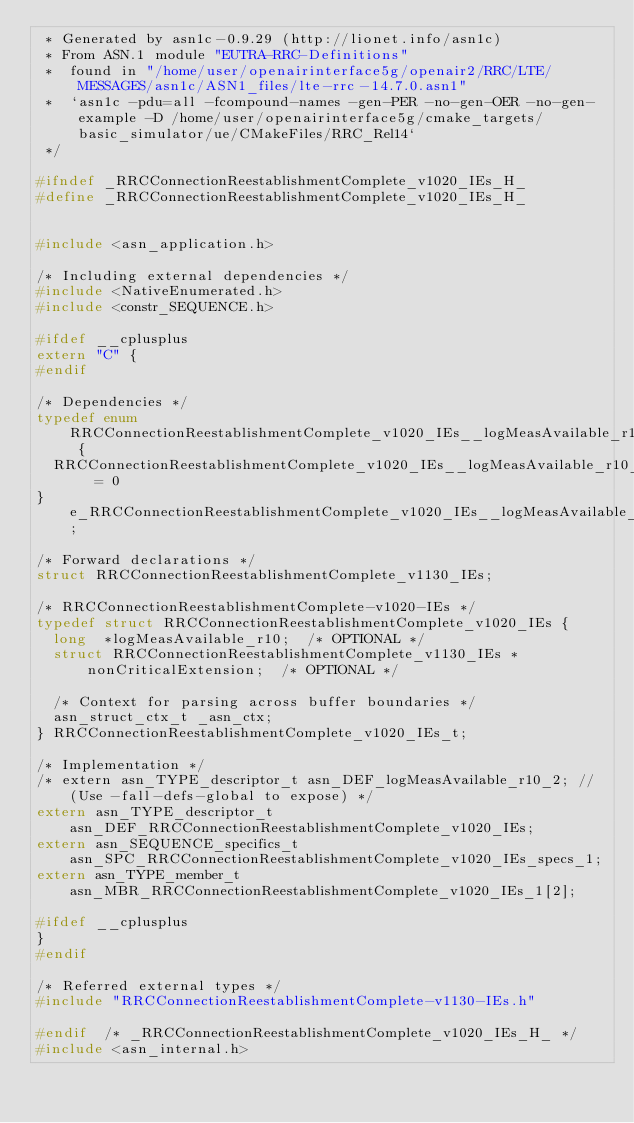Convert code to text. <code><loc_0><loc_0><loc_500><loc_500><_C_> * Generated by asn1c-0.9.29 (http://lionet.info/asn1c)
 * From ASN.1 module "EUTRA-RRC-Definitions"
 * 	found in "/home/user/openairinterface5g/openair2/RRC/LTE/MESSAGES/asn1c/ASN1_files/lte-rrc-14.7.0.asn1"
 * 	`asn1c -pdu=all -fcompound-names -gen-PER -no-gen-OER -no-gen-example -D /home/user/openairinterface5g/cmake_targets/basic_simulator/ue/CMakeFiles/RRC_Rel14`
 */

#ifndef	_RRCConnectionReestablishmentComplete_v1020_IEs_H_
#define	_RRCConnectionReestablishmentComplete_v1020_IEs_H_


#include <asn_application.h>

/* Including external dependencies */
#include <NativeEnumerated.h>
#include <constr_SEQUENCE.h>

#ifdef __cplusplus
extern "C" {
#endif

/* Dependencies */
typedef enum RRCConnectionReestablishmentComplete_v1020_IEs__logMeasAvailable_r10 {
	RRCConnectionReestablishmentComplete_v1020_IEs__logMeasAvailable_r10_true	= 0
} e_RRCConnectionReestablishmentComplete_v1020_IEs__logMeasAvailable_r10;

/* Forward declarations */
struct RRCConnectionReestablishmentComplete_v1130_IEs;

/* RRCConnectionReestablishmentComplete-v1020-IEs */
typedef struct RRCConnectionReestablishmentComplete_v1020_IEs {
	long	*logMeasAvailable_r10;	/* OPTIONAL */
	struct RRCConnectionReestablishmentComplete_v1130_IEs	*nonCriticalExtension;	/* OPTIONAL */
	
	/* Context for parsing across buffer boundaries */
	asn_struct_ctx_t _asn_ctx;
} RRCConnectionReestablishmentComplete_v1020_IEs_t;

/* Implementation */
/* extern asn_TYPE_descriptor_t asn_DEF_logMeasAvailable_r10_2;	// (Use -fall-defs-global to expose) */
extern asn_TYPE_descriptor_t asn_DEF_RRCConnectionReestablishmentComplete_v1020_IEs;
extern asn_SEQUENCE_specifics_t asn_SPC_RRCConnectionReestablishmentComplete_v1020_IEs_specs_1;
extern asn_TYPE_member_t asn_MBR_RRCConnectionReestablishmentComplete_v1020_IEs_1[2];

#ifdef __cplusplus
}
#endif

/* Referred external types */
#include "RRCConnectionReestablishmentComplete-v1130-IEs.h"

#endif	/* _RRCConnectionReestablishmentComplete_v1020_IEs_H_ */
#include <asn_internal.h>
</code> 